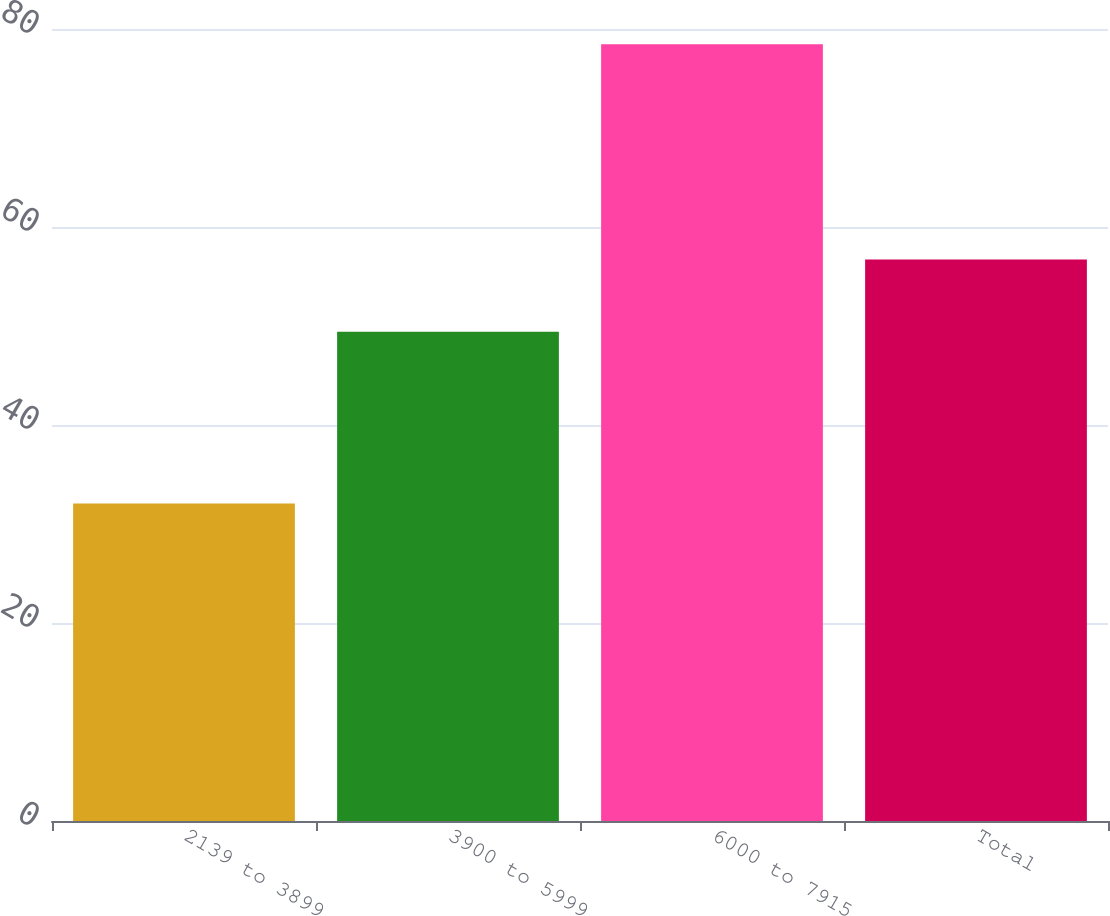Convert chart. <chart><loc_0><loc_0><loc_500><loc_500><bar_chart><fcel>2139 to 3899<fcel>3900 to 5999<fcel>6000 to 7915<fcel>Total<nl><fcel>32.06<fcel>49.43<fcel>78.47<fcel>56.71<nl></chart> 